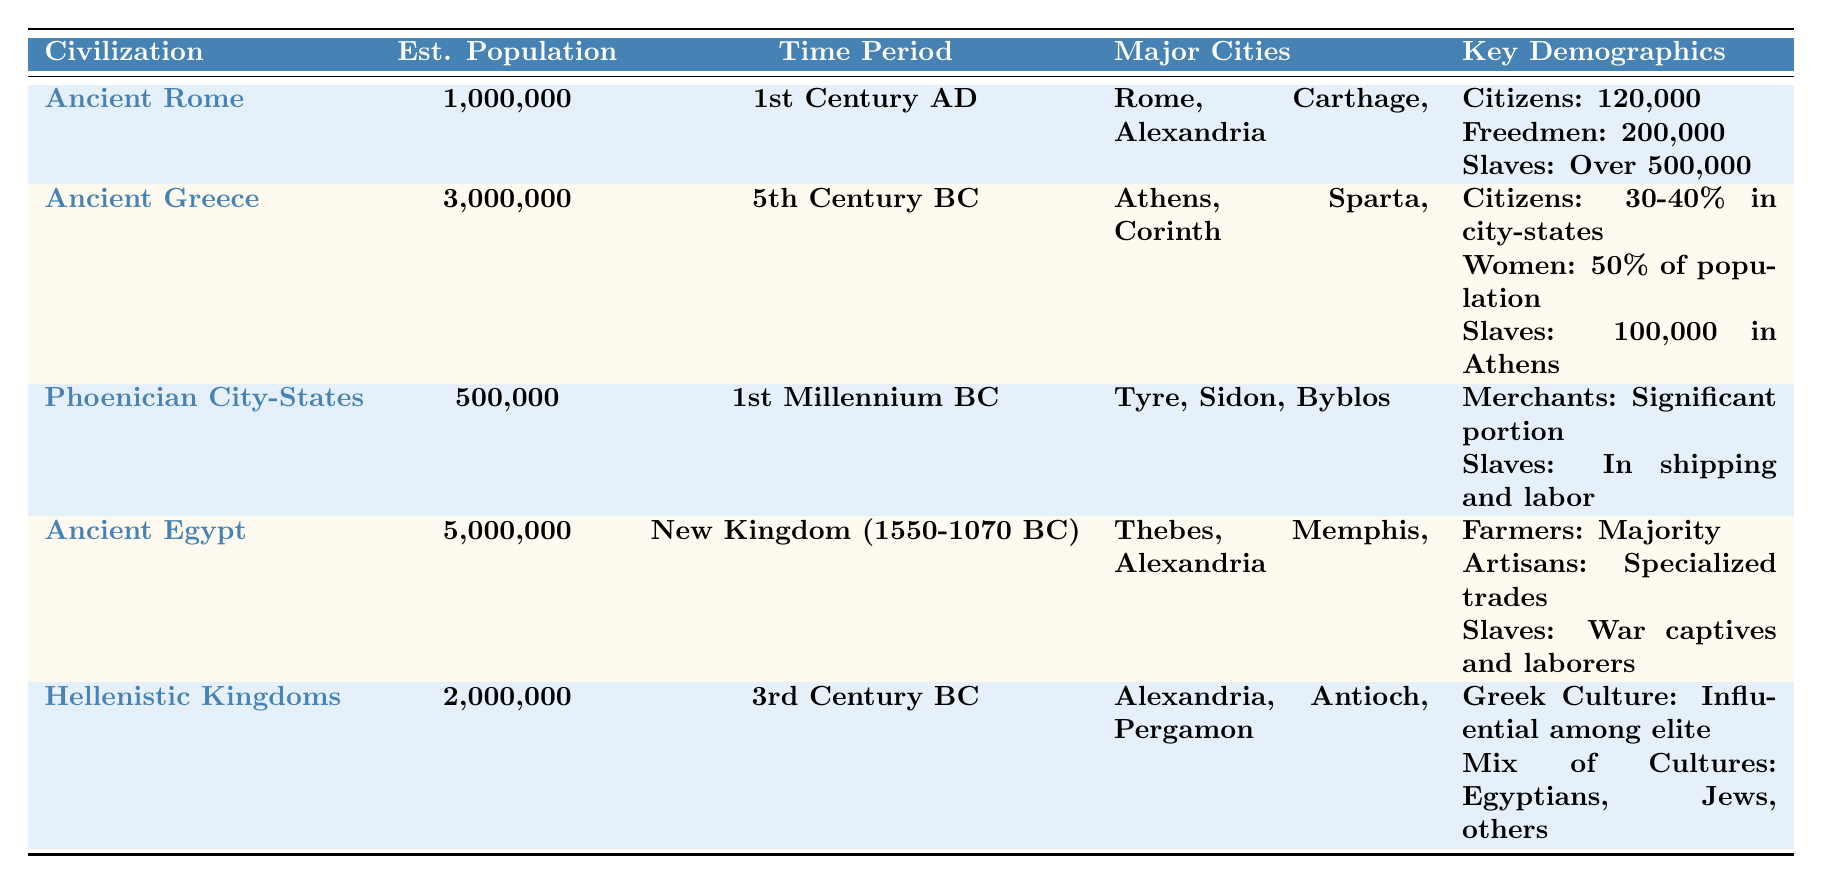What is the estimated population of Ancient Greece? According to the table, the estimated population of Ancient Greece is listed as 3,000,000.
Answer: 3,000,000 Which civilization had the highest estimated population? By comparing the estimated populations in the table, Ancient Egypt has the highest at 5,000,000.
Answer: Ancient Egypt How many major cities are listed for the Hellenistic Kingdoms? The table states that the major cities for the Hellenistic Kingdoms are Alexandria, Antioch, and Pergamon, which totals to three cities.
Answer: 3 What percentage of the population in Athens were citizens during the 5th century BC? The table indicates that citizens constituted around 30-40% in city-states like Athens.
Answer: 30-40% What was the estimated number of slaves in Ancient Rome? The table specifies that there were over 500,000 slaves in Ancient Rome.
Answer: Over 500,000 If you combine the estimated populations of Ancient Greece and the Hellenistic Kingdoms, what is the total? Adding the estimated populations: 3,000,000 (Ancient Greece) + 2,000,000 (Hellenistic Kingdoms) equals 5,000,000.
Answer: 5,000,000 Did the Phoenician City-States include a significant portion of merchants? Yes, the table states that a significant portion of the population in Phoenician City-States were merchants.
Answer: Yes Which civilization had a majority of farmers according to the key demographics? The key demographics for Ancient Egypt indicate that the majority of the population were farmers.
Answer: Ancient Egypt What is the estimated population difference between Ancient Rome and Ancient Egypt? The estimated population of Ancient Rome is 1,000,000 and Ancient Egypt is 5,000,000. The difference is 5,000,000 - 1,000,000 = 4,000,000.
Answer: 4,000,000 Are there any civilizations listed with a population of less than 1,000,000? Yes, both the Phoenician City-States and Ancient Rome have populations listed as less than 1,000,000 (500,000 and 1,000,000, respectively).
Answer: Yes 